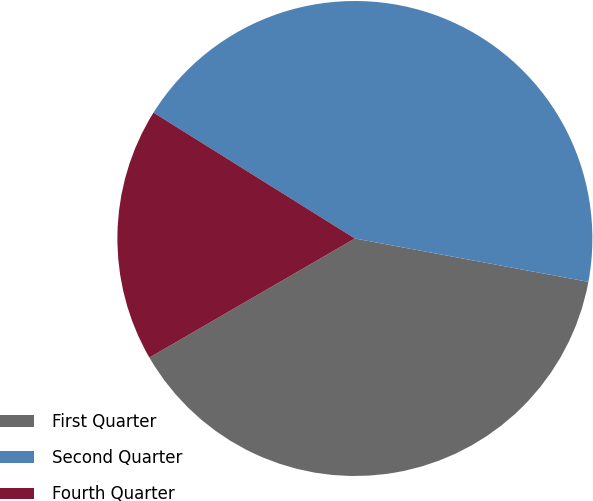Convert chart to OTSL. <chart><loc_0><loc_0><loc_500><loc_500><pie_chart><fcel>First Quarter<fcel>Second Quarter<fcel>Fourth Quarter<nl><fcel>38.72%<fcel>44.03%<fcel>17.25%<nl></chart> 